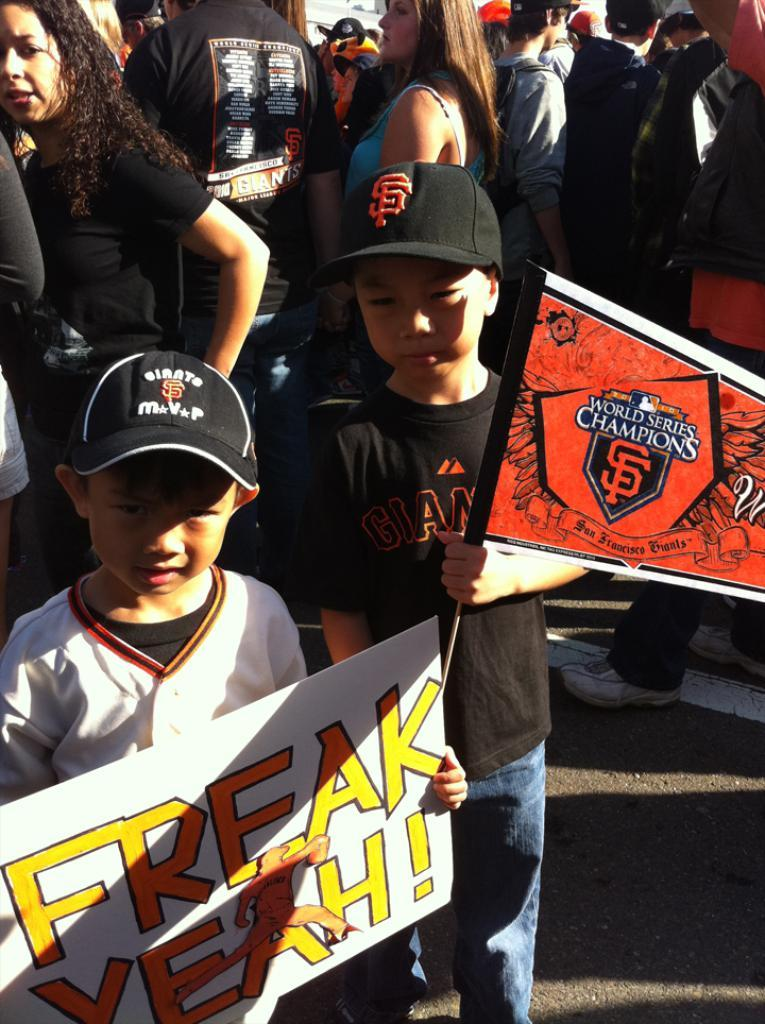Provide a one-sentence caption for the provided image. Two young boys at a baseball game one holding a World Champions pin and one holding a sign. 